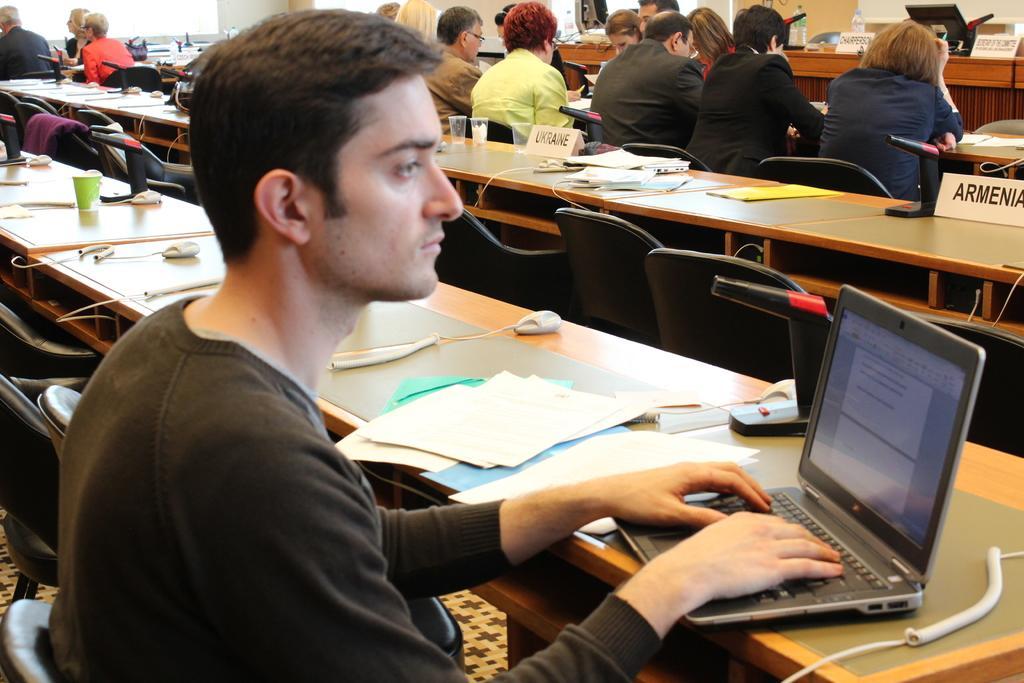Describe this image in one or two sentences. In this picture we can see some people are sitting on chairs in front of tables, there is a laptop in the front, we can see some papers, wires, name boards and glasses on these tables. 